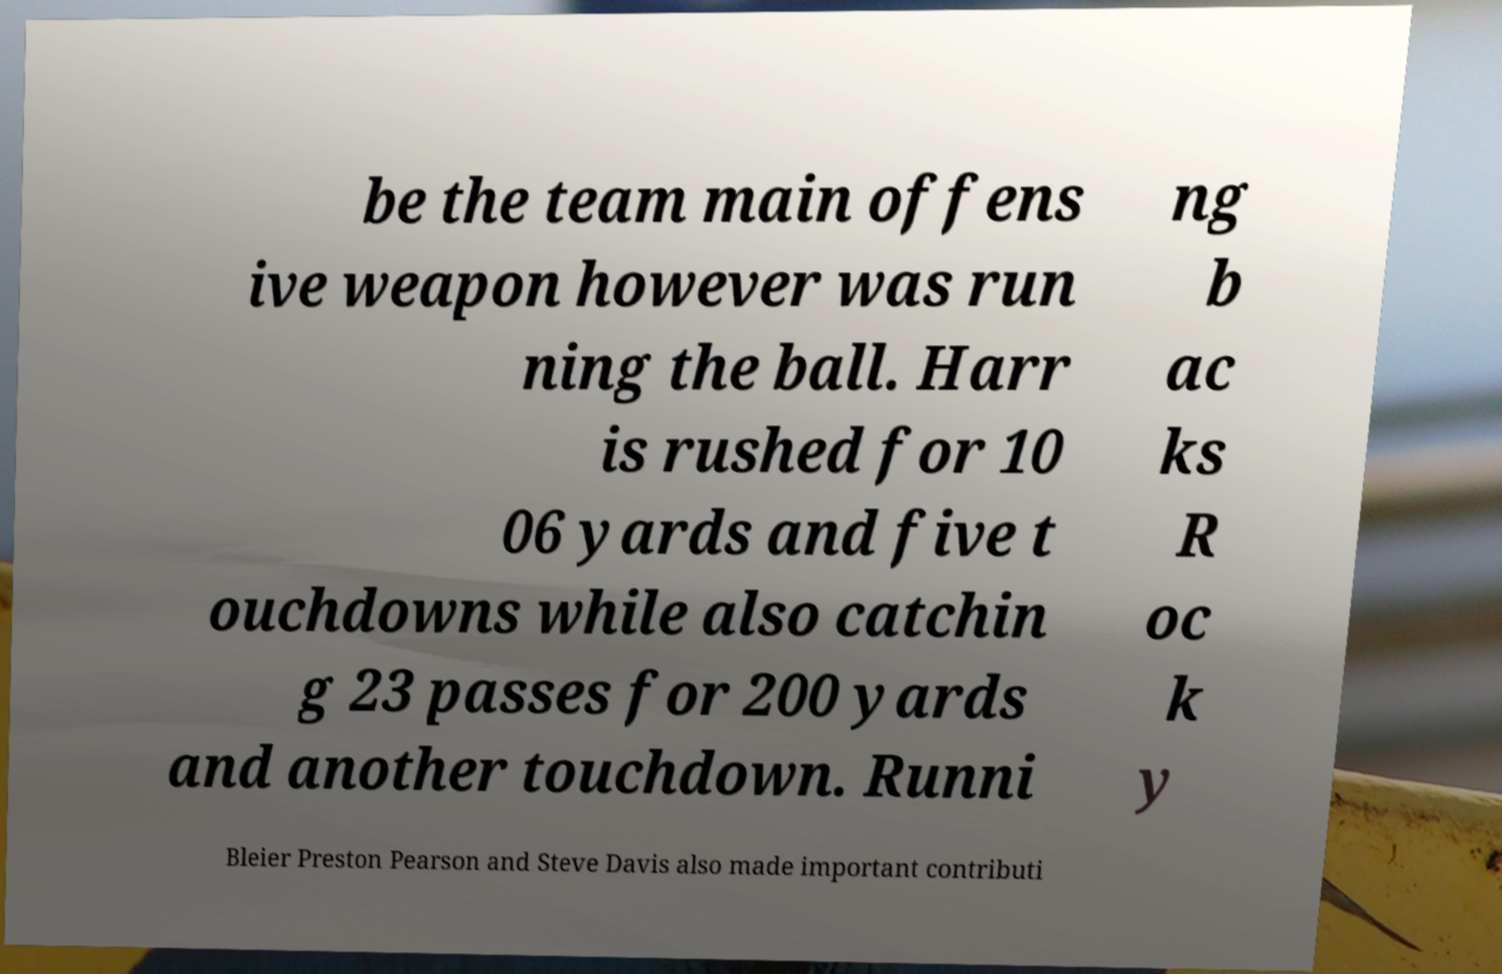For documentation purposes, I need the text within this image transcribed. Could you provide that? be the team main offens ive weapon however was run ning the ball. Harr is rushed for 10 06 yards and five t ouchdowns while also catchin g 23 passes for 200 yards and another touchdown. Runni ng b ac ks R oc k y Bleier Preston Pearson and Steve Davis also made important contributi 